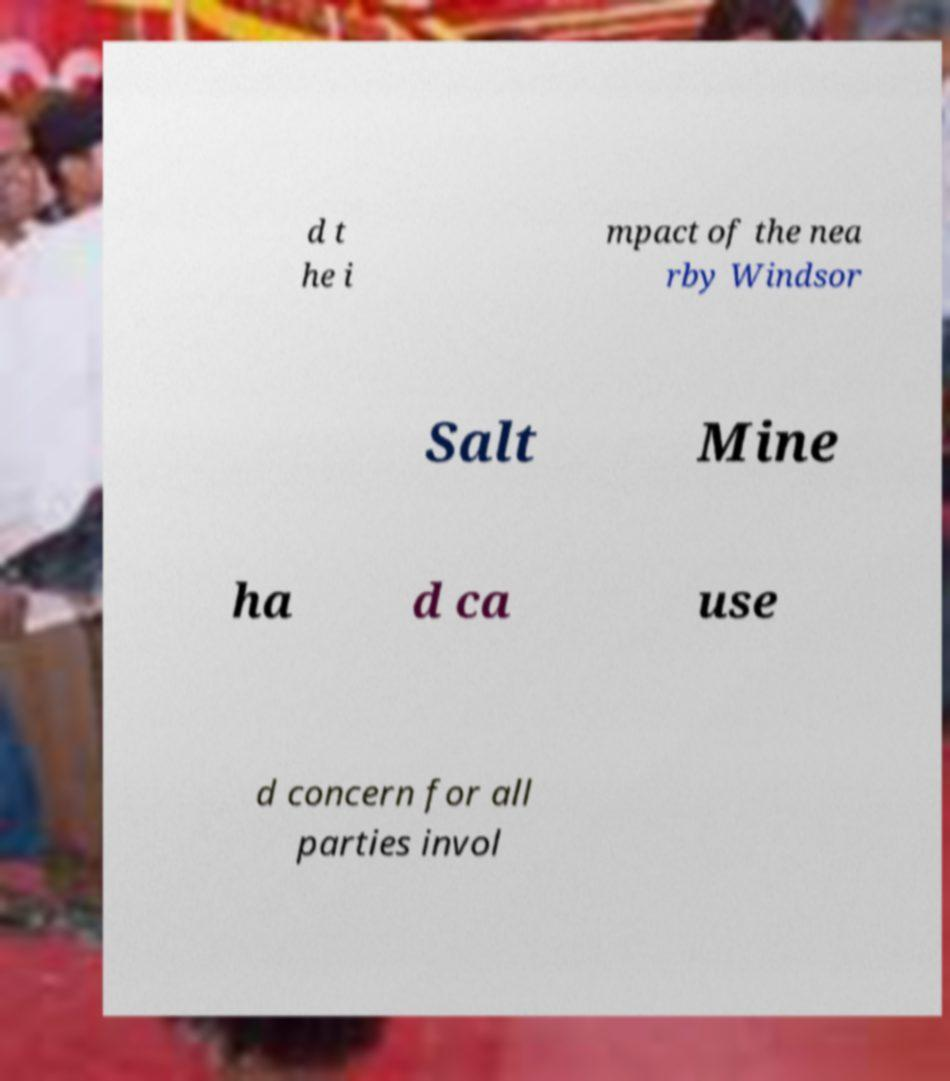What messages or text are displayed in this image? I need them in a readable, typed format. d t he i mpact of the nea rby Windsor Salt Mine ha d ca use d concern for all parties invol 